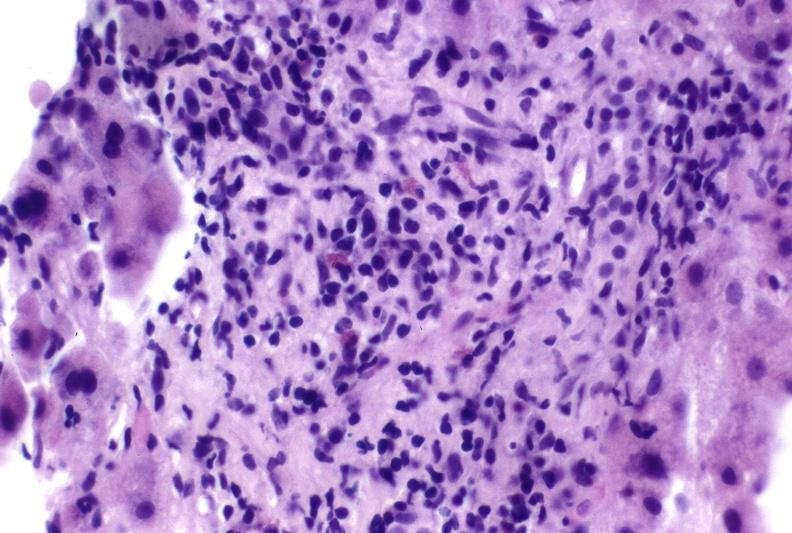s cysticercosis present?
Answer the question using a single word or phrase. No 